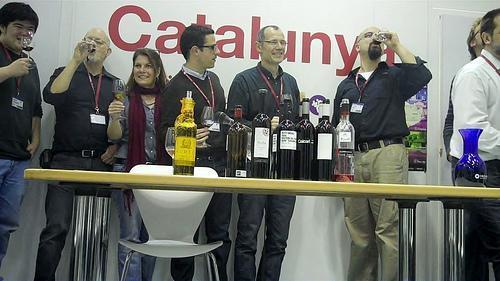How many women are in the picture?
Give a very brief answer. 1. How many people are in the picture?
Give a very brief answer. 8. 